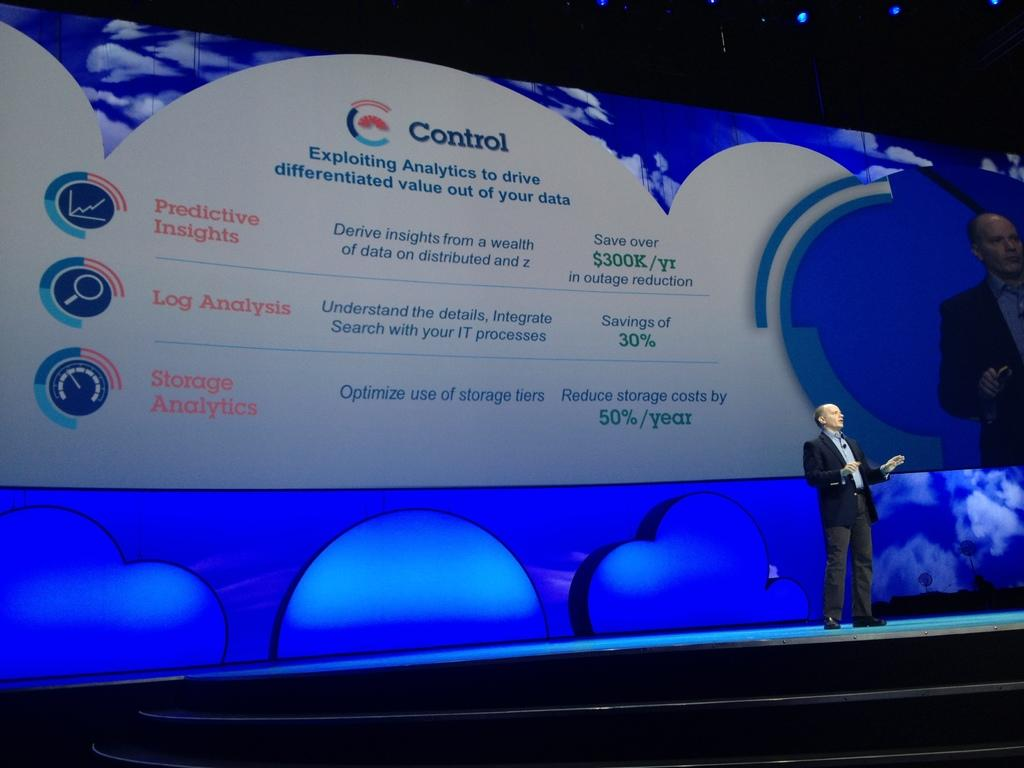<image>
Relay a brief, clear account of the picture shown. A man on a stage, with a large power point presentation behind him, is giving a speech on how to use analytics and data to improve a business. 